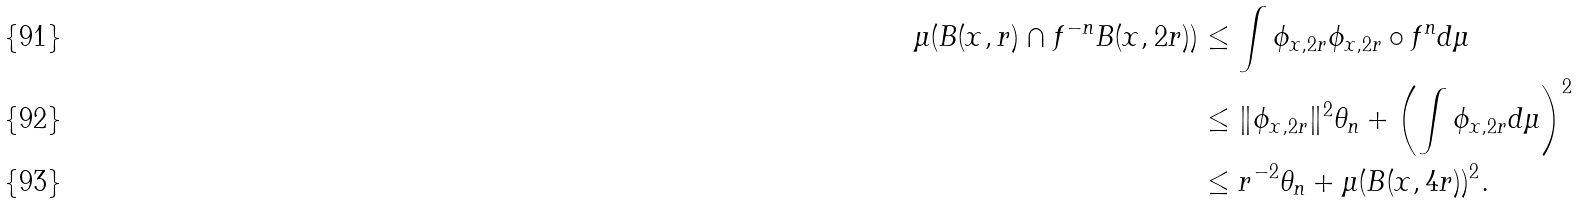<formula> <loc_0><loc_0><loc_500><loc_500>\mu ( B ( x , r ) \cap f ^ { - n } B ( x , 2 r ) ) & \leq \int \phi _ { x , 2 r } \phi _ { x , 2 r } \circ f ^ { n } d \mu \\ & \leq \| \phi _ { x , 2 r } \| ^ { 2 } \theta _ { n } + \left ( \int \phi _ { x , 2 r } d \mu \right ) ^ { 2 } \\ & \leq r ^ { - 2 } \theta _ { n } + \mu ( B ( x , 4 r ) ) ^ { 2 } .</formula> 